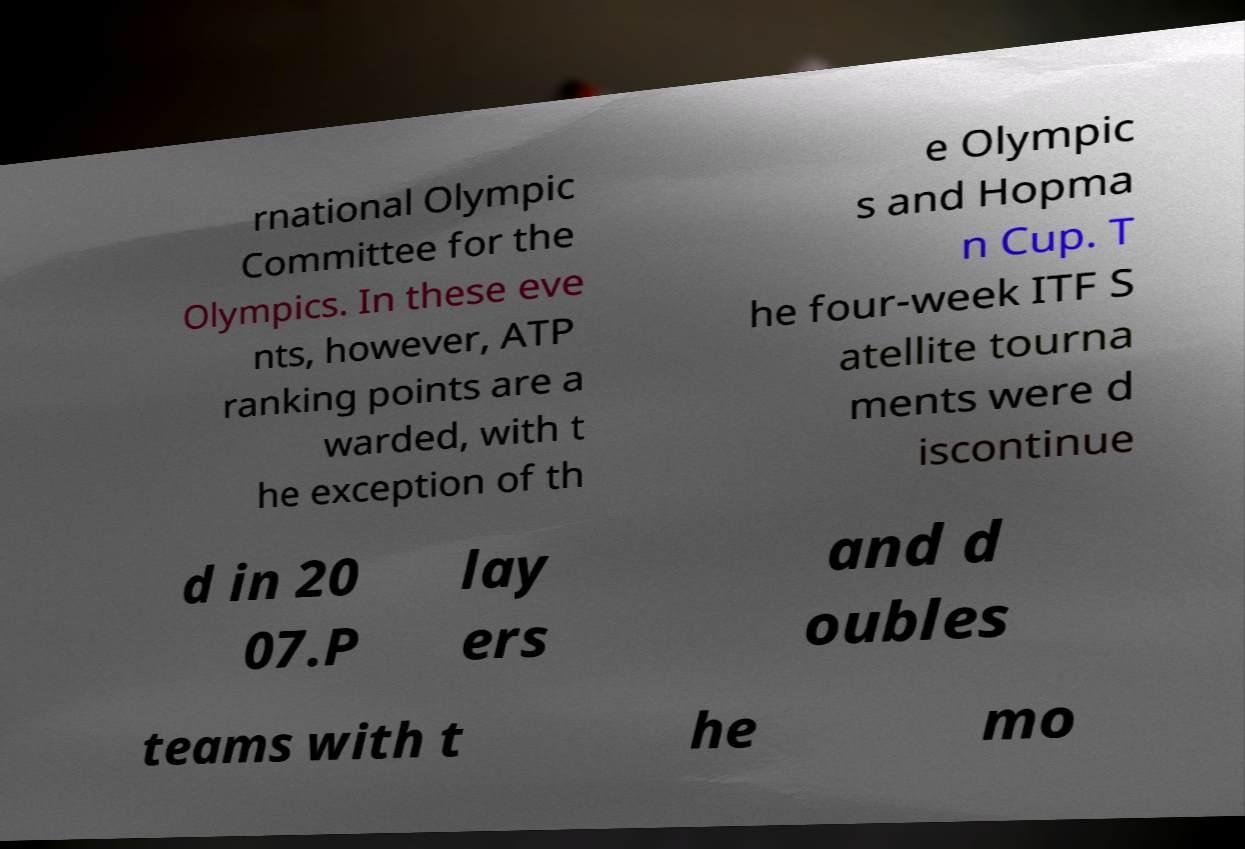There's text embedded in this image that I need extracted. Can you transcribe it verbatim? rnational Olympic Committee for the Olympics. In these eve nts, however, ATP ranking points are a warded, with t he exception of th e Olympic s and Hopma n Cup. T he four-week ITF S atellite tourna ments were d iscontinue d in 20 07.P lay ers and d oubles teams with t he mo 